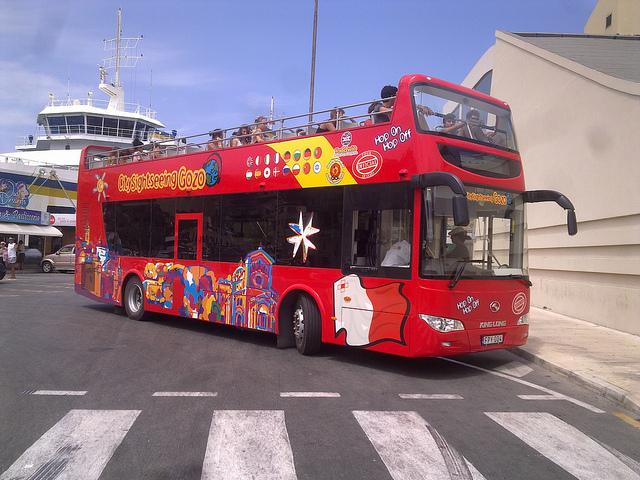What is the name for this type of vehicle?

Choices:
A) school
B) articulated
C) double decker
D) off road double decker 